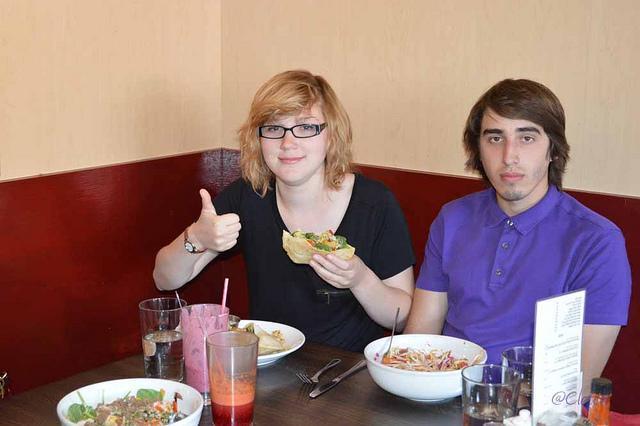How many people are male?
Give a very brief answer. 1. How many people are in the photo?
Give a very brief answer. 2. How many women are in this picture?
Give a very brief answer. 1. How many people are they in the picture?
Give a very brief answer. 2. How many bowls can be seen?
Give a very brief answer. 2. How many cups are in the photo?
Give a very brief answer. 4. 